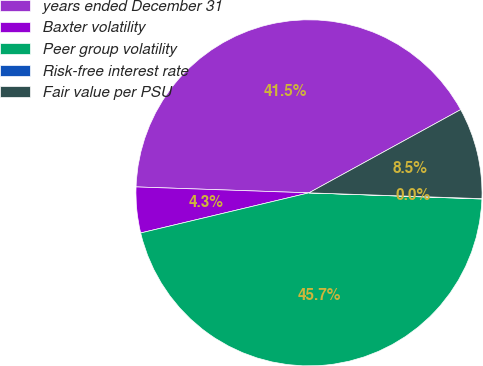Convert chart. <chart><loc_0><loc_0><loc_500><loc_500><pie_chart><fcel>years ended December 31<fcel>Baxter volatility<fcel>Peer group volatility<fcel>Risk-free interest rate<fcel>Fair value per PSU<nl><fcel>41.47%<fcel>4.27%<fcel>45.71%<fcel>0.03%<fcel>8.52%<nl></chart> 